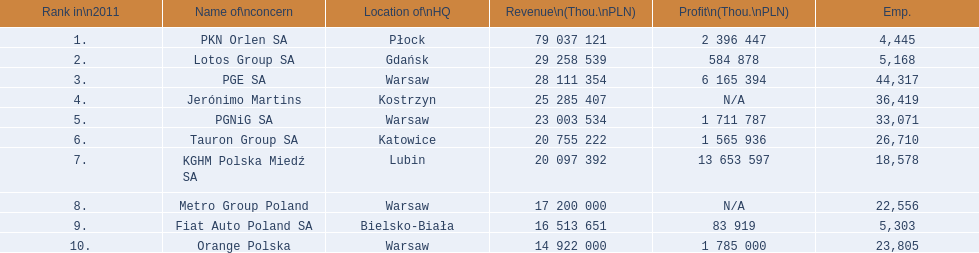What is the number of employees that work for pkn orlen sa in poland? 4,445. What number of employees work for lotos group sa? 5,168. How many people work for pgnig sa? 33,071. Could you parse the entire table? {'header': ['Rank in\\n2011', 'Name of\\nconcern', 'Location of\\nHQ', 'Revenue\\n(Thou.\\nPLN)', 'Profit\\n(Thou.\\nPLN)', 'Emp.'], 'rows': [['1.', 'PKN Orlen SA', 'Płock', '79 037 121', '2 396 447', '4,445'], ['2.', 'Lotos Group SA', 'Gdańsk', '29 258 539', '584 878', '5,168'], ['3.', 'PGE SA', 'Warsaw', '28 111 354', '6 165 394', '44,317'], ['4.', 'Jerónimo Martins', 'Kostrzyn', '25 285 407', 'N/A', '36,419'], ['5.', 'PGNiG SA', 'Warsaw', '23 003 534', '1 711 787', '33,071'], ['6.', 'Tauron Group SA', 'Katowice', '20 755 222', '1 565 936', '26,710'], ['7.', 'KGHM Polska Miedź SA', 'Lubin', '20 097 392', '13 653 597', '18,578'], ['8.', 'Metro Group Poland', 'Warsaw', '17 200 000', 'N/A', '22,556'], ['9.', 'Fiat Auto Poland SA', 'Bielsko-Biała', '16 513 651', '83 919', '5,303'], ['10.', 'Orange Polska', 'Warsaw', '14 922 000', '1 785 000', '23,805']]} 